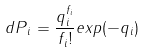Convert formula to latex. <formula><loc_0><loc_0><loc_500><loc_500>d P { _ { i } } = \frac { q _ { i } ^ { f _ { i } } } { f _ { i } ! } e x p ( - q _ { i } )</formula> 